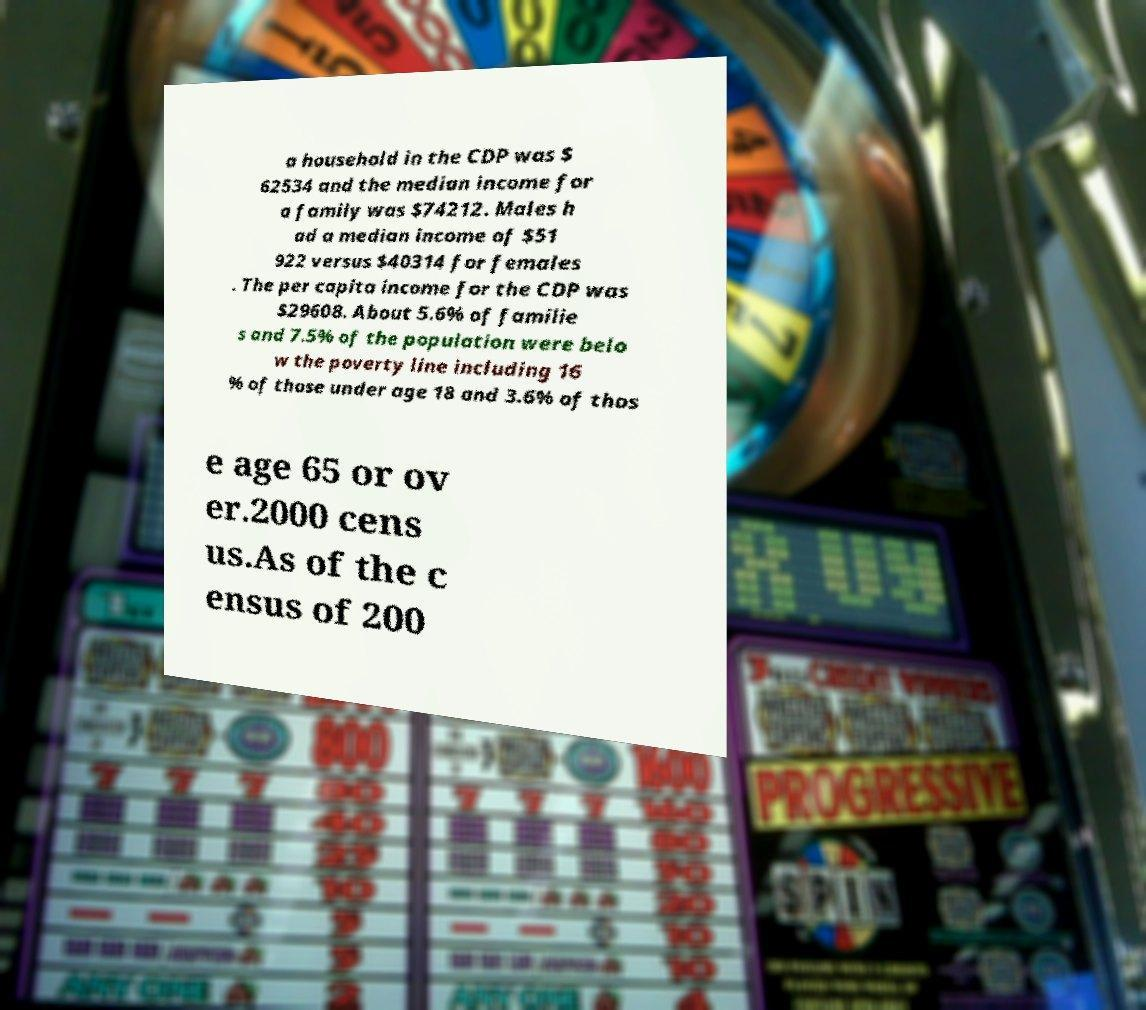Please read and relay the text visible in this image. What does it say? a household in the CDP was $ 62534 and the median income for a family was $74212. Males h ad a median income of $51 922 versus $40314 for females . The per capita income for the CDP was $29608. About 5.6% of familie s and 7.5% of the population were belo w the poverty line including 16 % of those under age 18 and 3.6% of thos e age 65 or ov er.2000 cens us.As of the c ensus of 200 